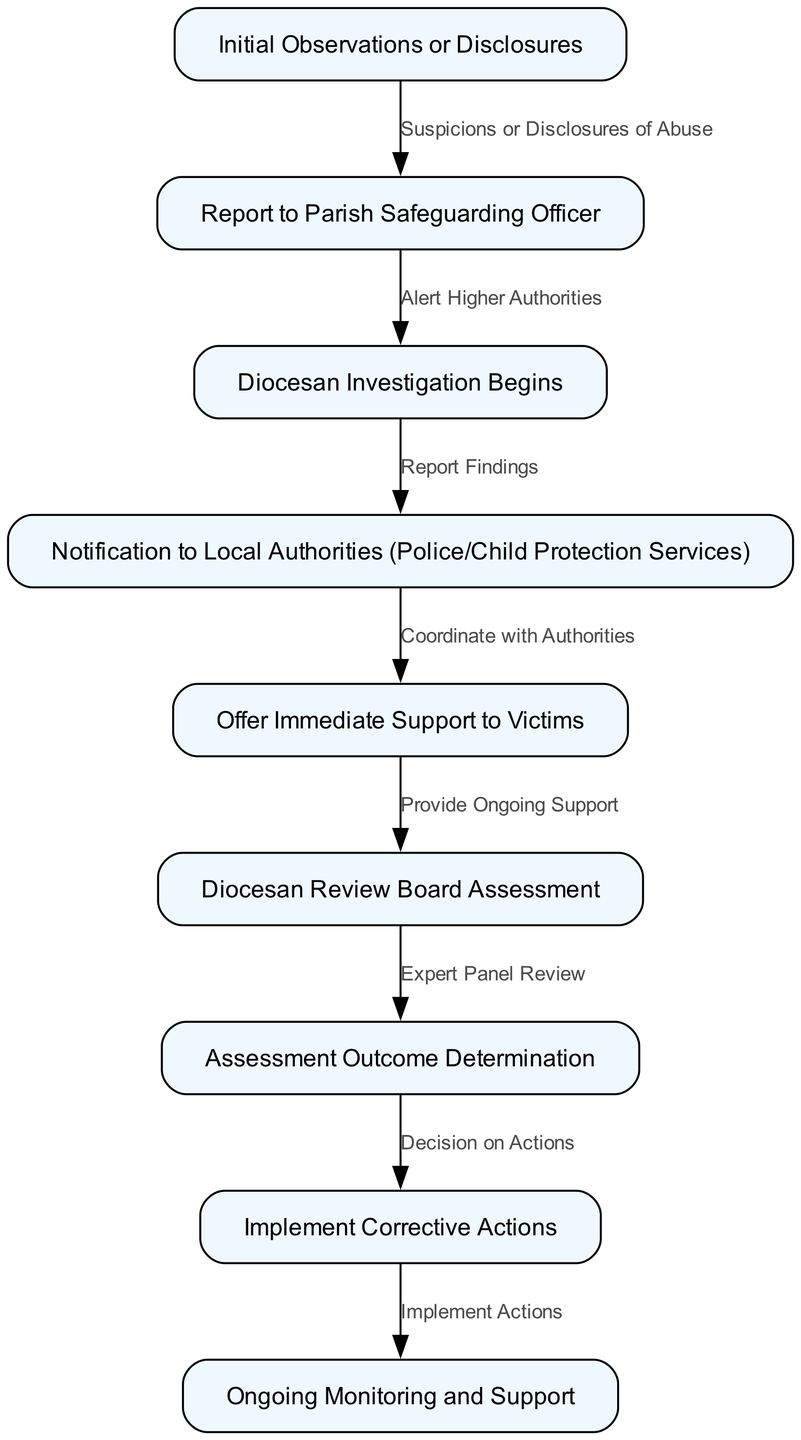What is the first step in the reporting process? The diagram starts with the node "Initial Observations or Disclosures," which indicates the first point of contact for reporting possible abuse.
Answer: Initial Observations or Disclosures How many nodes are present in the flowchart? By counting each distinct labeled rectangle in the diagram, there are a total of nine nodes listed.
Answer: Nine Which node follows the "Report to Parish Safeguarding Officer"? The flowchart indicates that after "Report to Parish Safeguarding Officer," the next step is "Diocesan Investigation Begins."
Answer: Diocesan Investigation Begins What action is taken after "Diocesan Investigation Begins"? Following "Diocesan Investigation Begins," the next node explains that there is a "Notification to Local Authorities (Police/Child Protection Services)."
Answer: Notification to Local Authorities (Police/Child Protection Services) How does support to victims relate to the notification to local authorities? The diagram depicts that once there is a notification to local authorities, the subsequent step is to "Offer Immediate Support to Victims," which shows that providing support is a key part of the process following a report.
Answer: Offer Immediate Support to Victims What comes after the "Diocesan Review Board Assessment"? The flowchart outlines that the next action after "Diocesan Review Board Assessment" is "Assessment Outcome Determination."
Answer: Assessment Outcome Determination What is the final step depicted in the flowchart? The last node represented in the flowchart indicates "Ongoing Monitoring and Support," which is the conclusion of the process.
Answer: Ongoing Monitoring and Support Which step involves a decision on actions to be taken? The diagram shows that the step labeled "Assessment Outcome Determination" leads to the "Implement Corrective Actions" step, where decisions regarding actions to be taken are made.
Answer: Implement Corrective Actions What type of professionals are involved in the assessment after victim support? According to the diagram, the assessment involves an "Expert Panel Review," indicating professional assessment and oversight in this stage.
Answer: Expert Panel Review 